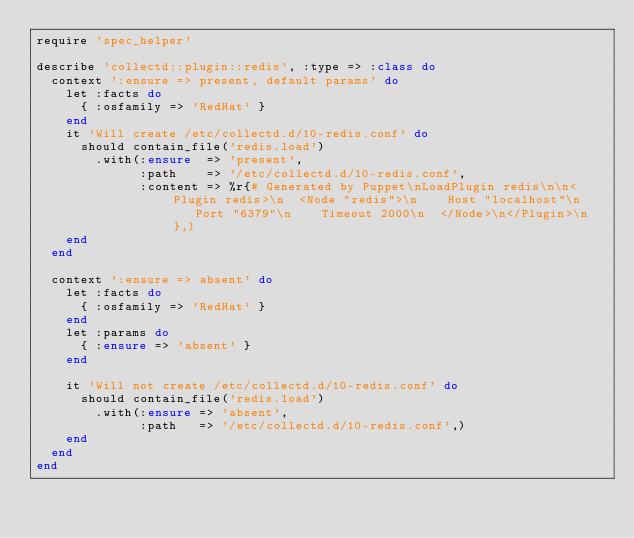<code> <loc_0><loc_0><loc_500><loc_500><_Ruby_>require 'spec_helper'

describe 'collectd::plugin::redis', :type => :class do
  context ':ensure => present, default params' do
    let :facts do
      { :osfamily => 'RedHat' }
    end
    it 'Will create /etc/collectd.d/10-redis.conf' do
      should contain_file('redis.load')
        .with(:ensure  => 'present',
              :path    => '/etc/collectd.d/10-redis.conf',
              :content => %r{# Generated by Puppet\nLoadPlugin redis\n\n<Plugin redis>\n  <Node "redis">\n    Host "localhost"\n    Port "6379"\n    Timeout 2000\n  </Node>\n</Plugin>\n},)
    end
  end

  context ':ensure => absent' do
    let :facts do
      { :osfamily => 'RedHat' }
    end
    let :params do
      { :ensure => 'absent' }
    end

    it 'Will not create /etc/collectd.d/10-redis.conf' do
      should contain_file('redis.load')
        .with(:ensure => 'absent',
              :path   => '/etc/collectd.d/10-redis.conf',)
    end
  end
end
</code> 